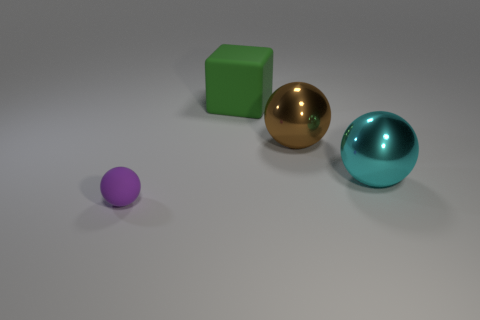Which object in the image seems to emit the most light, and why? None of the objects are emitting light; they are all illuminated by an external light source. However, the golden sphere reflects the most light due to its shiny, metallic surface, which causes it to appear the brightest. Could the shiny appearance of some objects affect the perception of their actual colors? Yes, the shininess can create highlights and reflections that may make the object's true color harder to discern. The surrounding colors and light conditions can also cast reflections that alter the perceived color of shiny objects. 